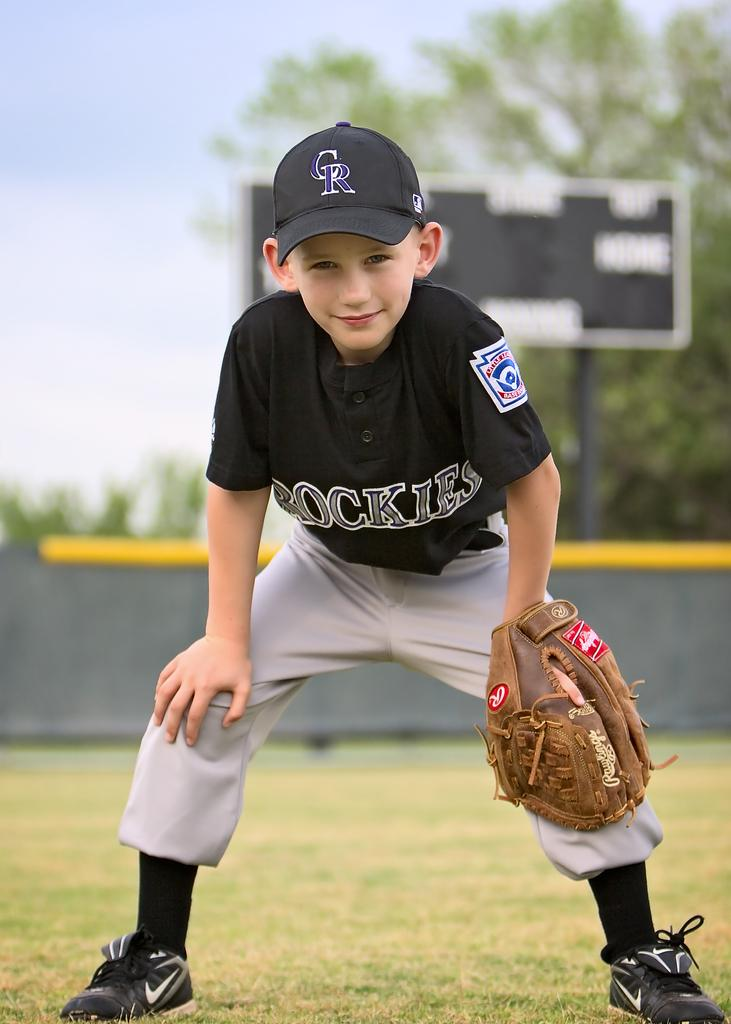<image>
Give a short and clear explanation of the subsequent image. The little league team called Rockies has several talented players. 